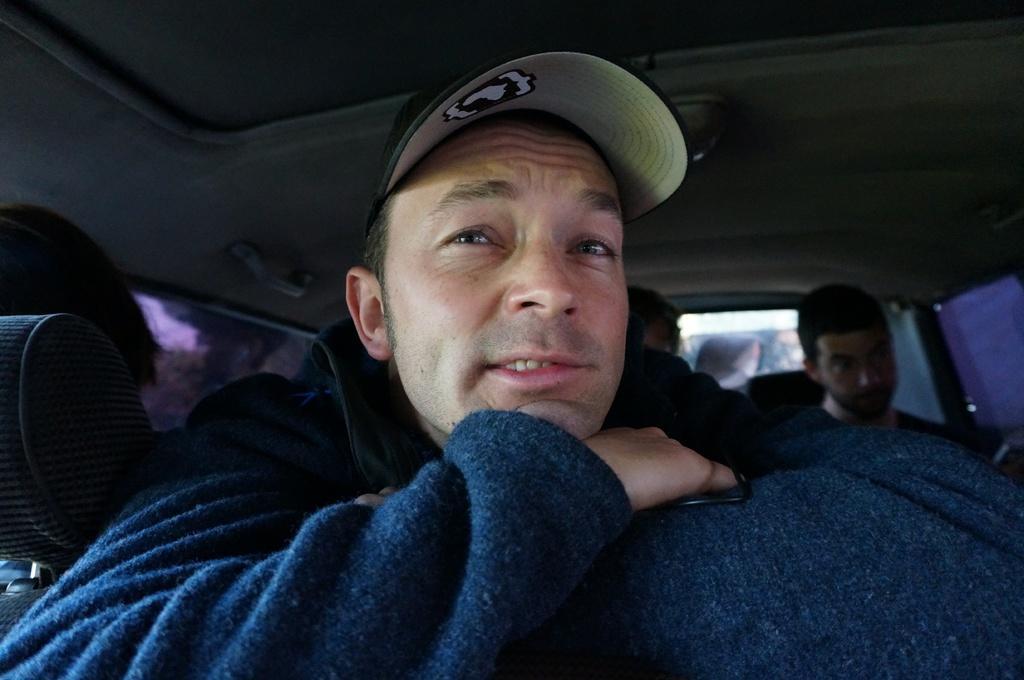Could you give a brief overview of what you see in this image? A picture inside of a car. These persons are sitting inside of a car. This man wore jacket and cap. 